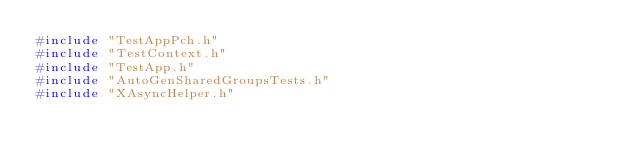Convert code to text. <code><loc_0><loc_0><loc_500><loc_500><_C++_>#include "TestAppPch.h"
#include "TestContext.h"
#include "TestApp.h"
#include "AutoGenSharedGroupsTests.h"
#include "XAsyncHelper.h"</code> 